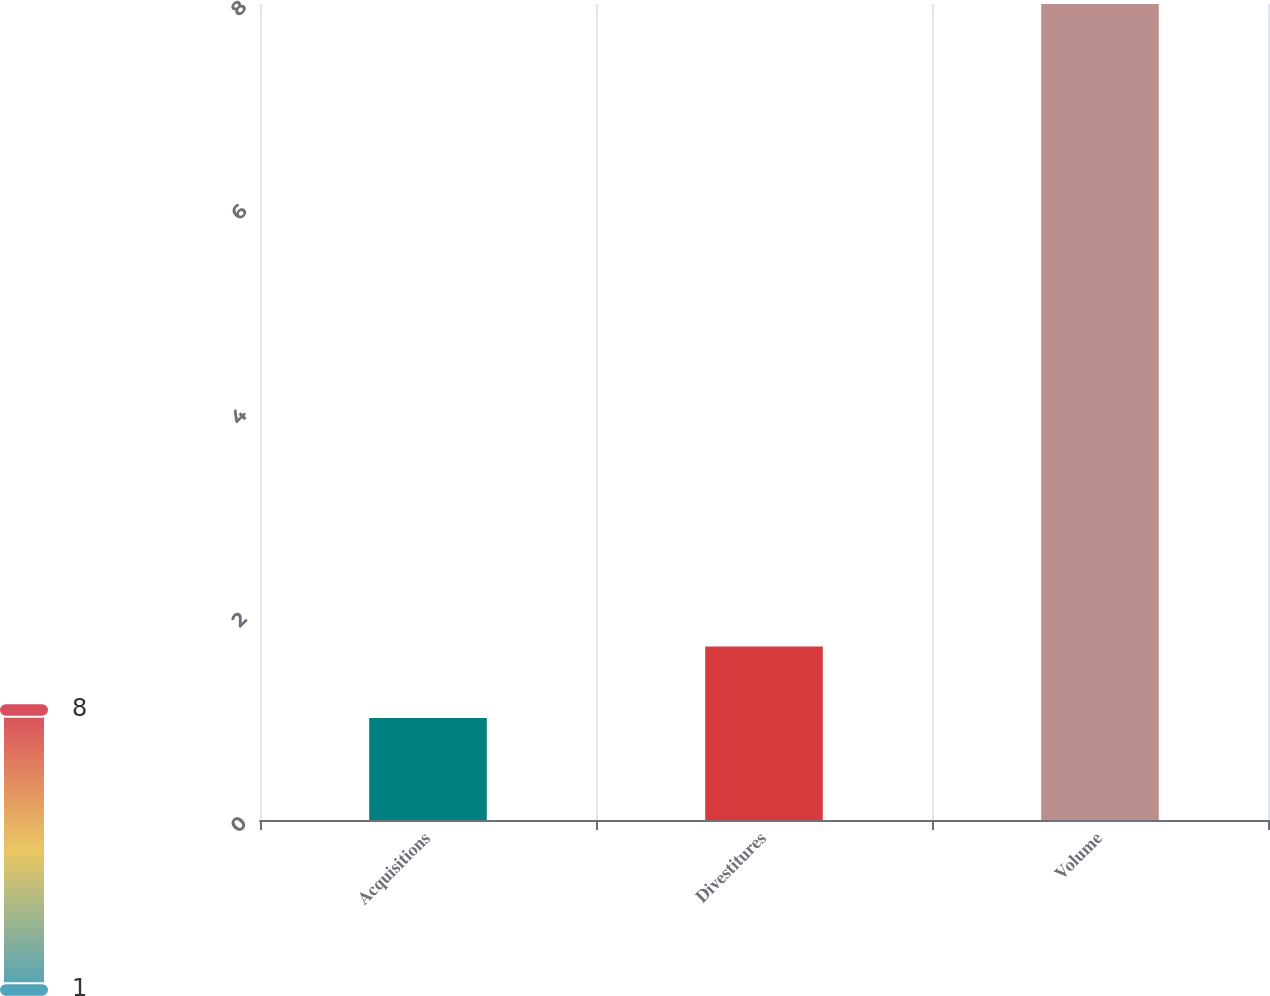Convert chart to OTSL. <chart><loc_0><loc_0><loc_500><loc_500><bar_chart><fcel>Acquisitions<fcel>Divestitures<fcel>Volume<nl><fcel>1<fcel>1.7<fcel>8<nl></chart> 